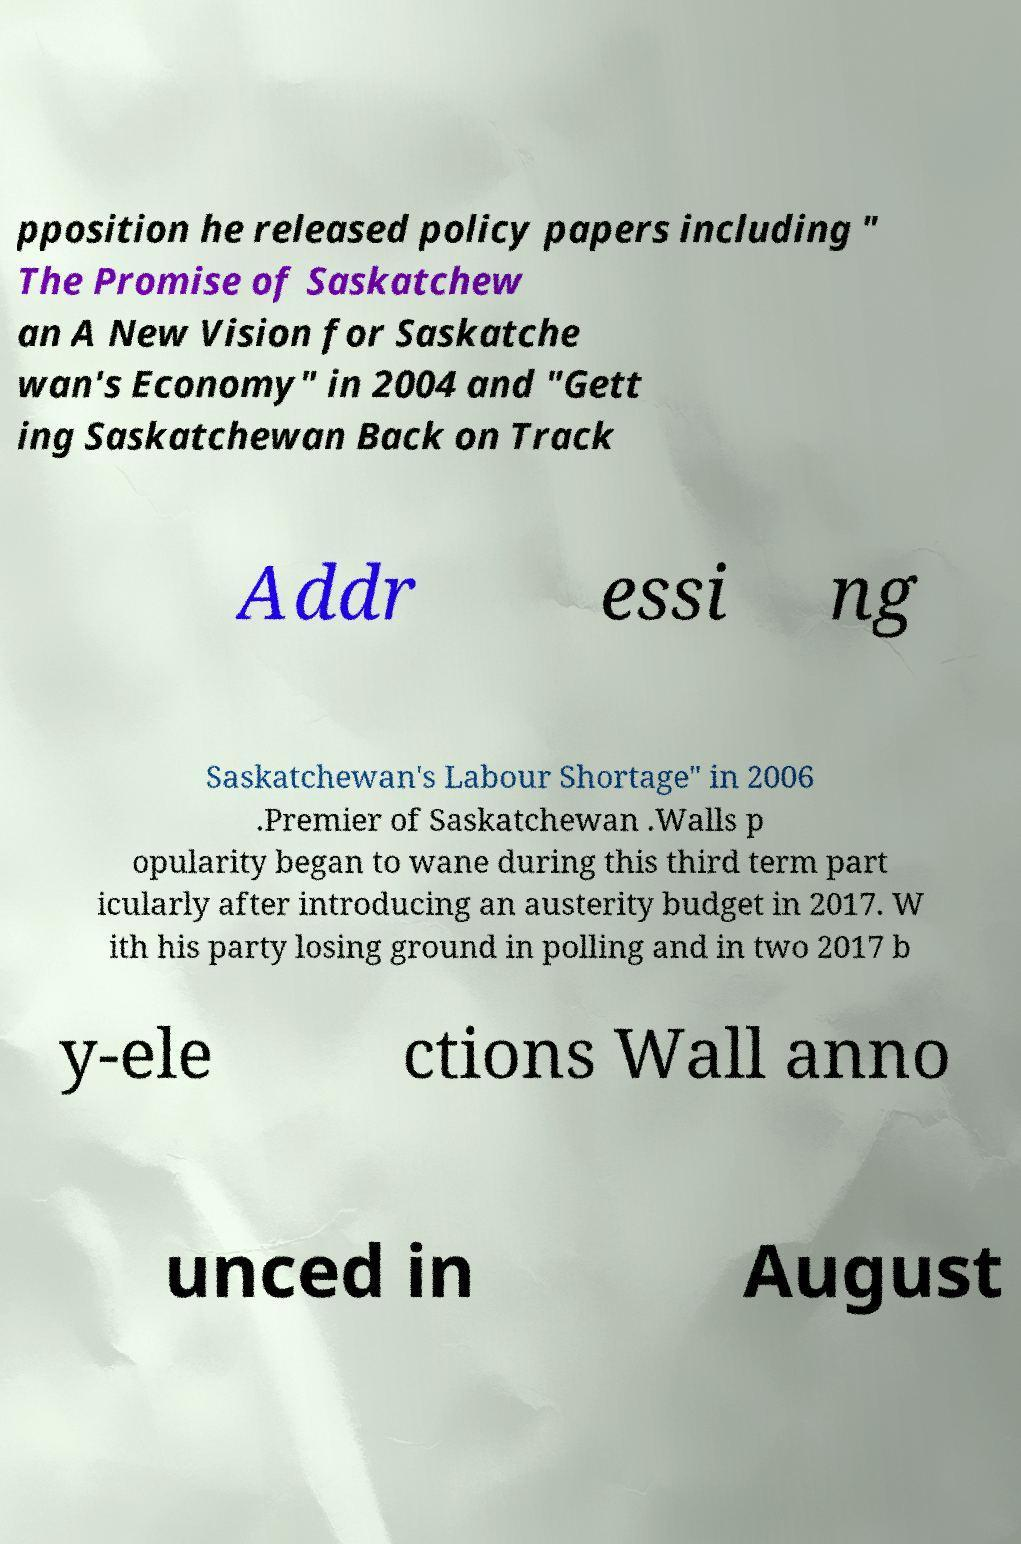Can you read and provide the text displayed in the image?This photo seems to have some interesting text. Can you extract and type it out for me? pposition he released policy papers including " The Promise of Saskatchew an A New Vision for Saskatche wan's Economy" in 2004 and "Gett ing Saskatchewan Back on Track Addr essi ng Saskatchewan's Labour Shortage" in 2006 .Premier of Saskatchewan .Walls p opularity began to wane during this third term part icularly after introducing an austerity budget in 2017. W ith his party losing ground in polling and in two 2017 b y-ele ctions Wall anno unced in August 